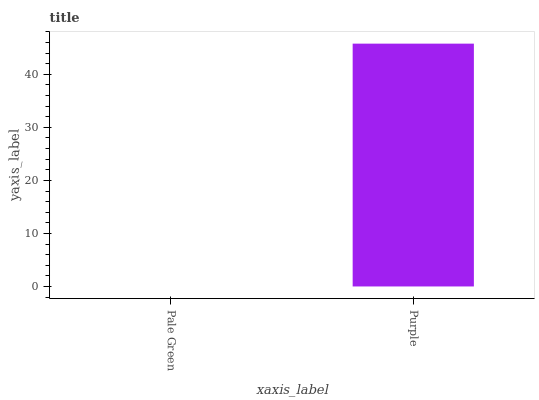Is Pale Green the minimum?
Answer yes or no. Yes. Is Purple the maximum?
Answer yes or no. Yes. Is Purple the minimum?
Answer yes or no. No. Is Purple greater than Pale Green?
Answer yes or no. Yes. Is Pale Green less than Purple?
Answer yes or no. Yes. Is Pale Green greater than Purple?
Answer yes or no. No. Is Purple less than Pale Green?
Answer yes or no. No. Is Purple the high median?
Answer yes or no. Yes. Is Pale Green the low median?
Answer yes or no. Yes. Is Pale Green the high median?
Answer yes or no. No. Is Purple the low median?
Answer yes or no. No. 